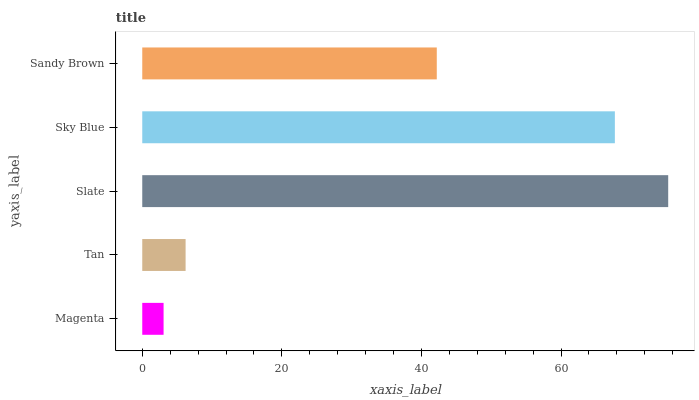Is Magenta the minimum?
Answer yes or no. Yes. Is Slate the maximum?
Answer yes or no. Yes. Is Tan the minimum?
Answer yes or no. No. Is Tan the maximum?
Answer yes or no. No. Is Tan greater than Magenta?
Answer yes or no. Yes. Is Magenta less than Tan?
Answer yes or no. Yes. Is Magenta greater than Tan?
Answer yes or no. No. Is Tan less than Magenta?
Answer yes or no. No. Is Sandy Brown the high median?
Answer yes or no. Yes. Is Sandy Brown the low median?
Answer yes or no. Yes. Is Magenta the high median?
Answer yes or no. No. Is Magenta the low median?
Answer yes or no. No. 